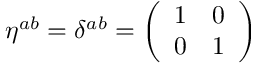<formula> <loc_0><loc_0><loc_500><loc_500>\eta ^ { a b } = \delta ^ { a b } = \left ( \begin{array} { c c } { 1 } & { 0 } \\ { 0 } & { 1 } \end{array} \right )</formula> 